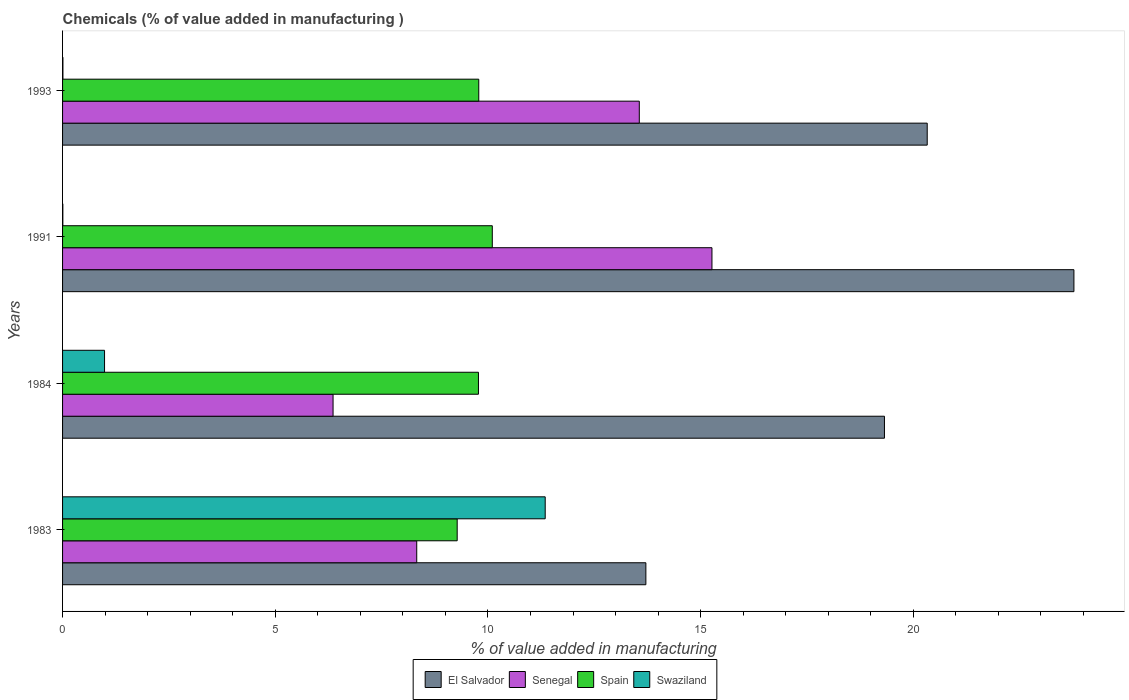What is the value added in manufacturing chemicals in Swaziland in 1984?
Offer a very short reply. 0.99. Across all years, what is the maximum value added in manufacturing chemicals in Swaziland?
Make the answer very short. 11.35. Across all years, what is the minimum value added in manufacturing chemicals in Spain?
Your answer should be very brief. 9.28. In which year was the value added in manufacturing chemicals in El Salvador minimum?
Offer a very short reply. 1983. What is the total value added in manufacturing chemicals in Senegal in the graph?
Offer a terse response. 43.51. What is the difference between the value added in manufacturing chemicals in El Salvador in 1983 and that in 1991?
Provide a succinct answer. -10.06. What is the difference between the value added in manufacturing chemicals in Swaziland in 1991 and the value added in manufacturing chemicals in Spain in 1983?
Provide a short and direct response. -9.27. What is the average value added in manufacturing chemicals in Senegal per year?
Your response must be concise. 10.88. In the year 1984, what is the difference between the value added in manufacturing chemicals in El Salvador and value added in manufacturing chemicals in Spain?
Keep it short and to the point. 9.54. In how many years, is the value added in manufacturing chemicals in Senegal greater than 16 %?
Make the answer very short. 0. What is the ratio of the value added in manufacturing chemicals in El Salvador in 1984 to that in 1991?
Provide a short and direct response. 0.81. Is the difference between the value added in manufacturing chemicals in El Salvador in 1984 and 1993 greater than the difference between the value added in manufacturing chemicals in Spain in 1984 and 1993?
Provide a short and direct response. No. What is the difference between the highest and the second highest value added in manufacturing chemicals in Spain?
Your answer should be very brief. 0.32. What is the difference between the highest and the lowest value added in manufacturing chemicals in Senegal?
Ensure brevity in your answer.  8.91. In how many years, is the value added in manufacturing chemicals in Swaziland greater than the average value added in manufacturing chemicals in Swaziland taken over all years?
Ensure brevity in your answer.  1. Is it the case that in every year, the sum of the value added in manufacturing chemicals in Senegal and value added in manufacturing chemicals in Spain is greater than the sum of value added in manufacturing chemicals in Swaziland and value added in manufacturing chemicals in El Salvador?
Make the answer very short. No. What does the 3rd bar from the top in 1984 represents?
Offer a terse response. Senegal. What does the 4th bar from the bottom in 1984 represents?
Your answer should be compact. Swaziland. How many bars are there?
Your answer should be very brief. 16. Are all the bars in the graph horizontal?
Offer a very short reply. Yes. Does the graph contain any zero values?
Your response must be concise. No. What is the title of the graph?
Offer a very short reply. Chemicals (% of value added in manufacturing ). What is the label or title of the X-axis?
Keep it short and to the point. % of value added in manufacturing. What is the % of value added in manufacturing in El Salvador in 1983?
Ensure brevity in your answer.  13.71. What is the % of value added in manufacturing of Senegal in 1983?
Your response must be concise. 8.33. What is the % of value added in manufacturing in Spain in 1983?
Provide a succinct answer. 9.28. What is the % of value added in manufacturing in Swaziland in 1983?
Make the answer very short. 11.35. What is the % of value added in manufacturing of El Salvador in 1984?
Offer a very short reply. 19.32. What is the % of value added in manufacturing of Senegal in 1984?
Offer a terse response. 6.36. What is the % of value added in manufacturing of Spain in 1984?
Keep it short and to the point. 9.78. What is the % of value added in manufacturing in Swaziland in 1984?
Your answer should be compact. 0.99. What is the % of value added in manufacturing of El Salvador in 1991?
Provide a succinct answer. 23.78. What is the % of value added in manufacturing of Senegal in 1991?
Offer a terse response. 15.27. What is the % of value added in manufacturing in Spain in 1991?
Your response must be concise. 10.1. What is the % of value added in manufacturing in Swaziland in 1991?
Ensure brevity in your answer.  0.01. What is the % of value added in manufacturing of El Salvador in 1993?
Provide a short and direct response. 20.33. What is the % of value added in manufacturing in Senegal in 1993?
Your answer should be compact. 13.56. What is the % of value added in manufacturing of Spain in 1993?
Your answer should be compact. 9.78. What is the % of value added in manufacturing of Swaziland in 1993?
Give a very brief answer. 0.01. Across all years, what is the maximum % of value added in manufacturing in El Salvador?
Provide a short and direct response. 23.78. Across all years, what is the maximum % of value added in manufacturing in Senegal?
Make the answer very short. 15.27. Across all years, what is the maximum % of value added in manufacturing in Spain?
Ensure brevity in your answer.  10.1. Across all years, what is the maximum % of value added in manufacturing in Swaziland?
Make the answer very short. 11.35. Across all years, what is the minimum % of value added in manufacturing in El Salvador?
Your answer should be very brief. 13.71. Across all years, what is the minimum % of value added in manufacturing in Senegal?
Provide a succinct answer. 6.36. Across all years, what is the minimum % of value added in manufacturing of Spain?
Keep it short and to the point. 9.28. Across all years, what is the minimum % of value added in manufacturing in Swaziland?
Provide a succinct answer. 0.01. What is the total % of value added in manufacturing in El Salvador in the graph?
Offer a very short reply. 77.14. What is the total % of value added in manufacturing of Senegal in the graph?
Keep it short and to the point. 43.51. What is the total % of value added in manufacturing in Spain in the graph?
Make the answer very short. 38.94. What is the total % of value added in manufacturing in Swaziland in the graph?
Your answer should be compact. 12.35. What is the difference between the % of value added in manufacturing of El Salvador in 1983 and that in 1984?
Provide a succinct answer. -5.61. What is the difference between the % of value added in manufacturing of Senegal in 1983 and that in 1984?
Keep it short and to the point. 1.97. What is the difference between the % of value added in manufacturing in Swaziland in 1983 and that in 1984?
Offer a very short reply. 10.36. What is the difference between the % of value added in manufacturing of El Salvador in 1983 and that in 1991?
Your answer should be compact. -10.06. What is the difference between the % of value added in manufacturing of Senegal in 1983 and that in 1991?
Provide a succinct answer. -6.94. What is the difference between the % of value added in manufacturing of Spain in 1983 and that in 1991?
Your answer should be compact. -0.83. What is the difference between the % of value added in manufacturing in Swaziland in 1983 and that in 1991?
Provide a succinct answer. 11.34. What is the difference between the % of value added in manufacturing in El Salvador in 1983 and that in 1993?
Your response must be concise. -6.61. What is the difference between the % of value added in manufacturing in Senegal in 1983 and that in 1993?
Make the answer very short. -5.23. What is the difference between the % of value added in manufacturing of Spain in 1983 and that in 1993?
Keep it short and to the point. -0.51. What is the difference between the % of value added in manufacturing of Swaziland in 1983 and that in 1993?
Keep it short and to the point. 11.34. What is the difference between the % of value added in manufacturing in El Salvador in 1984 and that in 1991?
Provide a short and direct response. -4.45. What is the difference between the % of value added in manufacturing of Senegal in 1984 and that in 1991?
Your answer should be compact. -8.91. What is the difference between the % of value added in manufacturing in Spain in 1984 and that in 1991?
Offer a terse response. -0.33. What is the difference between the % of value added in manufacturing in Swaziland in 1984 and that in 1991?
Ensure brevity in your answer.  0.98. What is the difference between the % of value added in manufacturing of El Salvador in 1984 and that in 1993?
Offer a very short reply. -1.01. What is the difference between the % of value added in manufacturing in Senegal in 1984 and that in 1993?
Your response must be concise. -7.2. What is the difference between the % of value added in manufacturing of Spain in 1984 and that in 1993?
Make the answer very short. -0.01. What is the difference between the % of value added in manufacturing in Swaziland in 1984 and that in 1993?
Provide a short and direct response. 0.98. What is the difference between the % of value added in manufacturing of El Salvador in 1991 and that in 1993?
Offer a terse response. 3.45. What is the difference between the % of value added in manufacturing in Senegal in 1991 and that in 1993?
Offer a very short reply. 1.71. What is the difference between the % of value added in manufacturing of Spain in 1991 and that in 1993?
Make the answer very short. 0.32. What is the difference between the % of value added in manufacturing in Swaziland in 1991 and that in 1993?
Provide a short and direct response. -0. What is the difference between the % of value added in manufacturing of El Salvador in 1983 and the % of value added in manufacturing of Senegal in 1984?
Your answer should be very brief. 7.35. What is the difference between the % of value added in manufacturing of El Salvador in 1983 and the % of value added in manufacturing of Spain in 1984?
Provide a short and direct response. 3.94. What is the difference between the % of value added in manufacturing of El Salvador in 1983 and the % of value added in manufacturing of Swaziland in 1984?
Make the answer very short. 12.73. What is the difference between the % of value added in manufacturing in Senegal in 1983 and the % of value added in manufacturing in Spain in 1984?
Keep it short and to the point. -1.45. What is the difference between the % of value added in manufacturing of Senegal in 1983 and the % of value added in manufacturing of Swaziland in 1984?
Ensure brevity in your answer.  7.34. What is the difference between the % of value added in manufacturing of Spain in 1983 and the % of value added in manufacturing of Swaziland in 1984?
Offer a terse response. 8.29. What is the difference between the % of value added in manufacturing of El Salvador in 1983 and the % of value added in manufacturing of Senegal in 1991?
Give a very brief answer. -1.55. What is the difference between the % of value added in manufacturing of El Salvador in 1983 and the % of value added in manufacturing of Spain in 1991?
Ensure brevity in your answer.  3.61. What is the difference between the % of value added in manufacturing of El Salvador in 1983 and the % of value added in manufacturing of Swaziland in 1991?
Offer a terse response. 13.71. What is the difference between the % of value added in manufacturing in Senegal in 1983 and the % of value added in manufacturing in Spain in 1991?
Your answer should be very brief. -1.78. What is the difference between the % of value added in manufacturing of Senegal in 1983 and the % of value added in manufacturing of Swaziland in 1991?
Offer a terse response. 8.32. What is the difference between the % of value added in manufacturing of Spain in 1983 and the % of value added in manufacturing of Swaziland in 1991?
Provide a succinct answer. 9.27. What is the difference between the % of value added in manufacturing of El Salvador in 1983 and the % of value added in manufacturing of Senegal in 1993?
Ensure brevity in your answer.  0.15. What is the difference between the % of value added in manufacturing of El Salvador in 1983 and the % of value added in manufacturing of Spain in 1993?
Provide a succinct answer. 3.93. What is the difference between the % of value added in manufacturing of El Salvador in 1983 and the % of value added in manufacturing of Swaziland in 1993?
Give a very brief answer. 13.71. What is the difference between the % of value added in manufacturing of Senegal in 1983 and the % of value added in manufacturing of Spain in 1993?
Provide a succinct answer. -1.46. What is the difference between the % of value added in manufacturing in Senegal in 1983 and the % of value added in manufacturing in Swaziland in 1993?
Offer a very short reply. 8.32. What is the difference between the % of value added in manufacturing in Spain in 1983 and the % of value added in manufacturing in Swaziland in 1993?
Provide a succinct answer. 9.27. What is the difference between the % of value added in manufacturing of El Salvador in 1984 and the % of value added in manufacturing of Senegal in 1991?
Provide a succinct answer. 4.06. What is the difference between the % of value added in manufacturing of El Salvador in 1984 and the % of value added in manufacturing of Spain in 1991?
Provide a succinct answer. 9.22. What is the difference between the % of value added in manufacturing in El Salvador in 1984 and the % of value added in manufacturing in Swaziland in 1991?
Your answer should be compact. 19.32. What is the difference between the % of value added in manufacturing of Senegal in 1984 and the % of value added in manufacturing of Spain in 1991?
Offer a terse response. -3.74. What is the difference between the % of value added in manufacturing of Senegal in 1984 and the % of value added in manufacturing of Swaziland in 1991?
Keep it short and to the point. 6.35. What is the difference between the % of value added in manufacturing of Spain in 1984 and the % of value added in manufacturing of Swaziland in 1991?
Make the answer very short. 9.77. What is the difference between the % of value added in manufacturing in El Salvador in 1984 and the % of value added in manufacturing in Senegal in 1993?
Make the answer very short. 5.76. What is the difference between the % of value added in manufacturing in El Salvador in 1984 and the % of value added in manufacturing in Spain in 1993?
Your answer should be compact. 9.54. What is the difference between the % of value added in manufacturing of El Salvador in 1984 and the % of value added in manufacturing of Swaziland in 1993?
Provide a succinct answer. 19.31. What is the difference between the % of value added in manufacturing of Senegal in 1984 and the % of value added in manufacturing of Spain in 1993?
Give a very brief answer. -3.43. What is the difference between the % of value added in manufacturing in Senegal in 1984 and the % of value added in manufacturing in Swaziland in 1993?
Your response must be concise. 6.35. What is the difference between the % of value added in manufacturing of Spain in 1984 and the % of value added in manufacturing of Swaziland in 1993?
Offer a terse response. 9.77. What is the difference between the % of value added in manufacturing of El Salvador in 1991 and the % of value added in manufacturing of Senegal in 1993?
Your answer should be compact. 10.22. What is the difference between the % of value added in manufacturing in El Salvador in 1991 and the % of value added in manufacturing in Spain in 1993?
Provide a short and direct response. 13.99. What is the difference between the % of value added in manufacturing in El Salvador in 1991 and the % of value added in manufacturing in Swaziland in 1993?
Your answer should be very brief. 23.77. What is the difference between the % of value added in manufacturing of Senegal in 1991 and the % of value added in manufacturing of Spain in 1993?
Your response must be concise. 5.48. What is the difference between the % of value added in manufacturing of Senegal in 1991 and the % of value added in manufacturing of Swaziland in 1993?
Your answer should be very brief. 15.26. What is the difference between the % of value added in manufacturing in Spain in 1991 and the % of value added in manufacturing in Swaziland in 1993?
Provide a short and direct response. 10.09. What is the average % of value added in manufacturing in El Salvador per year?
Provide a short and direct response. 19.28. What is the average % of value added in manufacturing of Senegal per year?
Make the answer very short. 10.88. What is the average % of value added in manufacturing of Spain per year?
Ensure brevity in your answer.  9.74. What is the average % of value added in manufacturing of Swaziland per year?
Offer a terse response. 3.09. In the year 1983, what is the difference between the % of value added in manufacturing in El Salvador and % of value added in manufacturing in Senegal?
Your answer should be very brief. 5.39. In the year 1983, what is the difference between the % of value added in manufacturing in El Salvador and % of value added in manufacturing in Spain?
Give a very brief answer. 4.44. In the year 1983, what is the difference between the % of value added in manufacturing in El Salvador and % of value added in manufacturing in Swaziland?
Your answer should be very brief. 2.37. In the year 1983, what is the difference between the % of value added in manufacturing of Senegal and % of value added in manufacturing of Spain?
Your answer should be compact. -0.95. In the year 1983, what is the difference between the % of value added in manufacturing in Senegal and % of value added in manufacturing in Swaziland?
Your answer should be very brief. -3.02. In the year 1983, what is the difference between the % of value added in manufacturing in Spain and % of value added in manufacturing in Swaziland?
Give a very brief answer. -2.07. In the year 1984, what is the difference between the % of value added in manufacturing of El Salvador and % of value added in manufacturing of Senegal?
Provide a succinct answer. 12.96. In the year 1984, what is the difference between the % of value added in manufacturing in El Salvador and % of value added in manufacturing in Spain?
Ensure brevity in your answer.  9.54. In the year 1984, what is the difference between the % of value added in manufacturing of El Salvador and % of value added in manufacturing of Swaziland?
Your answer should be very brief. 18.34. In the year 1984, what is the difference between the % of value added in manufacturing in Senegal and % of value added in manufacturing in Spain?
Provide a short and direct response. -3.42. In the year 1984, what is the difference between the % of value added in manufacturing of Senegal and % of value added in manufacturing of Swaziland?
Provide a short and direct response. 5.37. In the year 1984, what is the difference between the % of value added in manufacturing of Spain and % of value added in manufacturing of Swaziland?
Offer a terse response. 8.79. In the year 1991, what is the difference between the % of value added in manufacturing of El Salvador and % of value added in manufacturing of Senegal?
Provide a succinct answer. 8.51. In the year 1991, what is the difference between the % of value added in manufacturing in El Salvador and % of value added in manufacturing in Spain?
Make the answer very short. 13.67. In the year 1991, what is the difference between the % of value added in manufacturing in El Salvador and % of value added in manufacturing in Swaziland?
Ensure brevity in your answer.  23.77. In the year 1991, what is the difference between the % of value added in manufacturing of Senegal and % of value added in manufacturing of Spain?
Make the answer very short. 5.16. In the year 1991, what is the difference between the % of value added in manufacturing in Senegal and % of value added in manufacturing in Swaziland?
Your answer should be very brief. 15.26. In the year 1991, what is the difference between the % of value added in manufacturing in Spain and % of value added in manufacturing in Swaziland?
Ensure brevity in your answer.  10.1. In the year 1993, what is the difference between the % of value added in manufacturing of El Salvador and % of value added in manufacturing of Senegal?
Your answer should be compact. 6.77. In the year 1993, what is the difference between the % of value added in manufacturing in El Salvador and % of value added in manufacturing in Spain?
Offer a very short reply. 10.54. In the year 1993, what is the difference between the % of value added in manufacturing in El Salvador and % of value added in manufacturing in Swaziland?
Keep it short and to the point. 20.32. In the year 1993, what is the difference between the % of value added in manufacturing of Senegal and % of value added in manufacturing of Spain?
Ensure brevity in your answer.  3.77. In the year 1993, what is the difference between the % of value added in manufacturing in Senegal and % of value added in manufacturing in Swaziland?
Your response must be concise. 13.55. In the year 1993, what is the difference between the % of value added in manufacturing of Spain and % of value added in manufacturing of Swaziland?
Make the answer very short. 9.78. What is the ratio of the % of value added in manufacturing in El Salvador in 1983 to that in 1984?
Provide a short and direct response. 0.71. What is the ratio of the % of value added in manufacturing of Senegal in 1983 to that in 1984?
Make the answer very short. 1.31. What is the ratio of the % of value added in manufacturing of Spain in 1983 to that in 1984?
Your response must be concise. 0.95. What is the ratio of the % of value added in manufacturing in Swaziland in 1983 to that in 1984?
Offer a very short reply. 11.5. What is the ratio of the % of value added in manufacturing of El Salvador in 1983 to that in 1991?
Your answer should be compact. 0.58. What is the ratio of the % of value added in manufacturing of Senegal in 1983 to that in 1991?
Keep it short and to the point. 0.55. What is the ratio of the % of value added in manufacturing in Spain in 1983 to that in 1991?
Give a very brief answer. 0.92. What is the ratio of the % of value added in manufacturing of Swaziland in 1983 to that in 1991?
Your answer should be very brief. 1742.11. What is the ratio of the % of value added in manufacturing in El Salvador in 1983 to that in 1993?
Provide a short and direct response. 0.67. What is the ratio of the % of value added in manufacturing of Senegal in 1983 to that in 1993?
Provide a short and direct response. 0.61. What is the ratio of the % of value added in manufacturing in Spain in 1983 to that in 1993?
Keep it short and to the point. 0.95. What is the ratio of the % of value added in manufacturing in Swaziland in 1983 to that in 1993?
Your response must be concise. 1366.74. What is the ratio of the % of value added in manufacturing of El Salvador in 1984 to that in 1991?
Provide a short and direct response. 0.81. What is the ratio of the % of value added in manufacturing in Senegal in 1984 to that in 1991?
Your answer should be compact. 0.42. What is the ratio of the % of value added in manufacturing in Spain in 1984 to that in 1991?
Offer a terse response. 0.97. What is the ratio of the % of value added in manufacturing in Swaziland in 1984 to that in 1991?
Offer a very short reply. 151.51. What is the ratio of the % of value added in manufacturing of El Salvador in 1984 to that in 1993?
Your response must be concise. 0.95. What is the ratio of the % of value added in manufacturing in Senegal in 1984 to that in 1993?
Your answer should be compact. 0.47. What is the ratio of the % of value added in manufacturing of Spain in 1984 to that in 1993?
Your answer should be compact. 1. What is the ratio of the % of value added in manufacturing of Swaziland in 1984 to that in 1993?
Your answer should be very brief. 118.87. What is the ratio of the % of value added in manufacturing of El Salvador in 1991 to that in 1993?
Your answer should be very brief. 1.17. What is the ratio of the % of value added in manufacturing of Senegal in 1991 to that in 1993?
Offer a very short reply. 1.13. What is the ratio of the % of value added in manufacturing of Spain in 1991 to that in 1993?
Give a very brief answer. 1.03. What is the ratio of the % of value added in manufacturing in Swaziland in 1991 to that in 1993?
Your answer should be compact. 0.78. What is the difference between the highest and the second highest % of value added in manufacturing of El Salvador?
Offer a very short reply. 3.45. What is the difference between the highest and the second highest % of value added in manufacturing of Senegal?
Provide a succinct answer. 1.71. What is the difference between the highest and the second highest % of value added in manufacturing of Spain?
Give a very brief answer. 0.32. What is the difference between the highest and the second highest % of value added in manufacturing of Swaziland?
Give a very brief answer. 10.36. What is the difference between the highest and the lowest % of value added in manufacturing of El Salvador?
Ensure brevity in your answer.  10.06. What is the difference between the highest and the lowest % of value added in manufacturing of Senegal?
Offer a terse response. 8.91. What is the difference between the highest and the lowest % of value added in manufacturing in Spain?
Make the answer very short. 0.83. What is the difference between the highest and the lowest % of value added in manufacturing in Swaziland?
Your answer should be very brief. 11.34. 